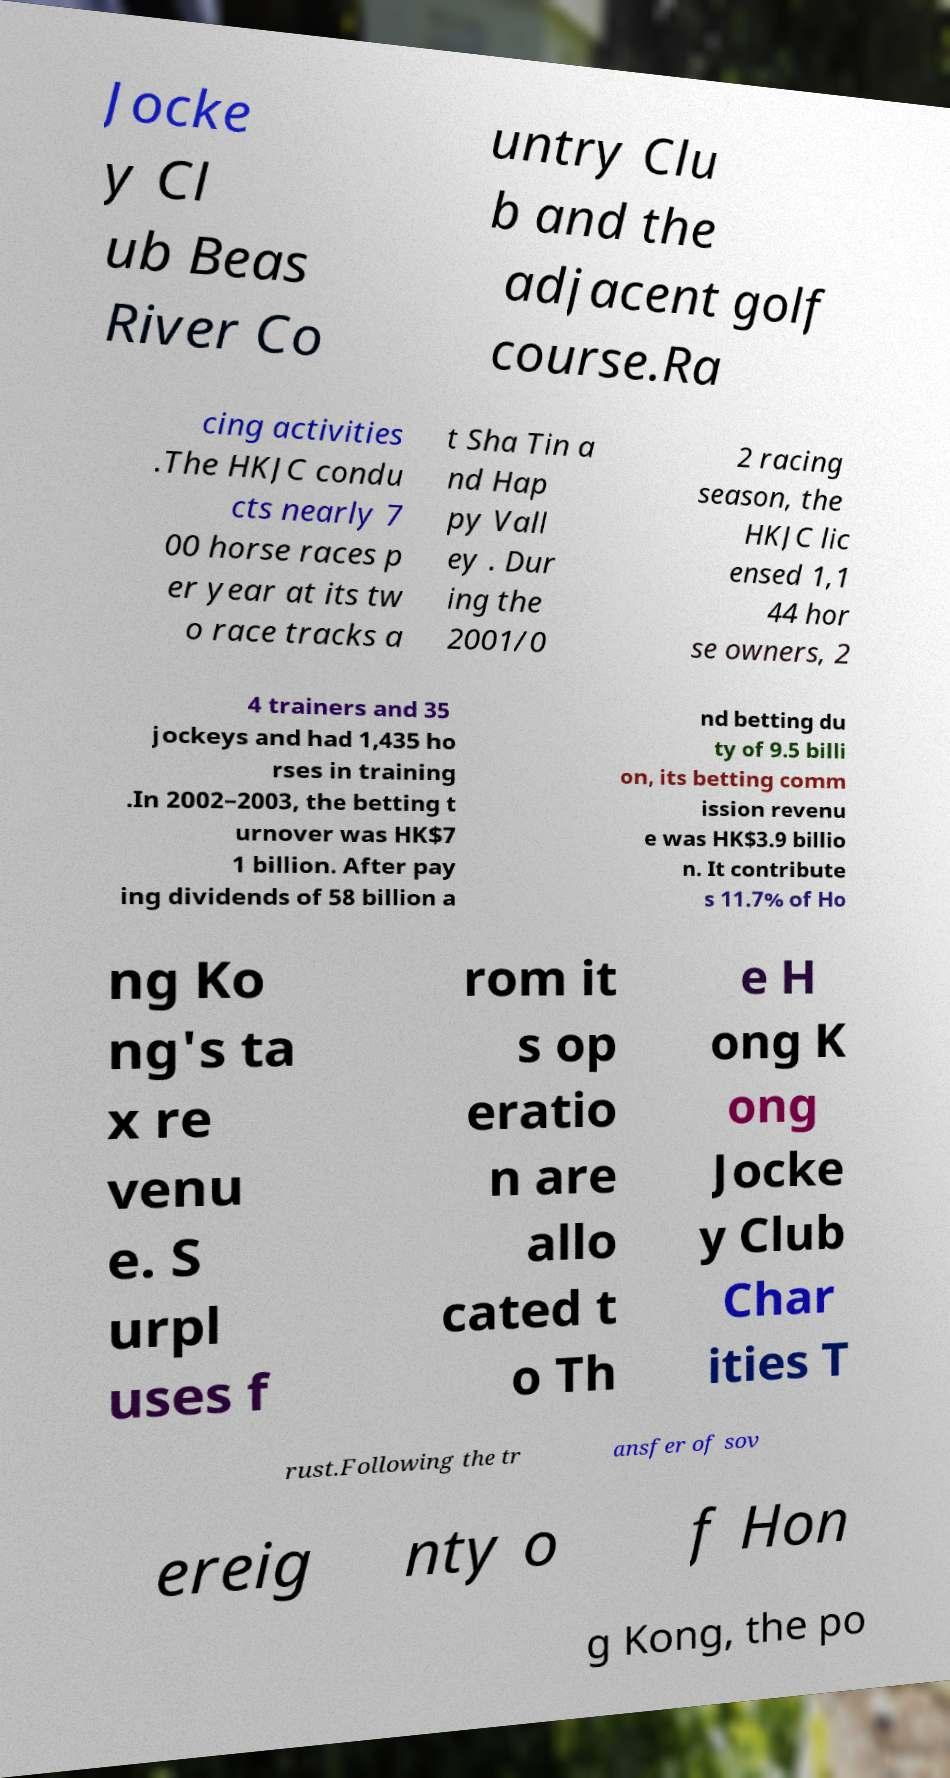I need the written content from this picture converted into text. Can you do that? Jocke y Cl ub Beas River Co untry Clu b and the adjacent golf course.Ra cing activities .The HKJC condu cts nearly 7 00 horse races p er year at its tw o race tracks a t Sha Tin a nd Hap py Vall ey . Dur ing the 2001/0 2 racing season, the HKJC lic ensed 1,1 44 hor se owners, 2 4 trainers and 35 jockeys and had 1,435 ho rses in training .In 2002–2003, the betting t urnover was HK$7 1 billion. After pay ing dividends of 58 billion a nd betting du ty of 9.5 billi on, its betting comm ission revenu e was HK$3.9 billio n. It contribute s 11.7% of Ho ng Ko ng's ta x re venu e. S urpl uses f rom it s op eratio n are allo cated t o Th e H ong K ong Jocke y Club Char ities T rust.Following the tr ansfer of sov ereig nty o f Hon g Kong, the po 